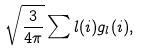<formula> <loc_0><loc_0><loc_500><loc_500>\sqrt { \frac { 3 } { 4 \pi } } \sum l ( i ) g _ { l } ( i ) ,</formula> 